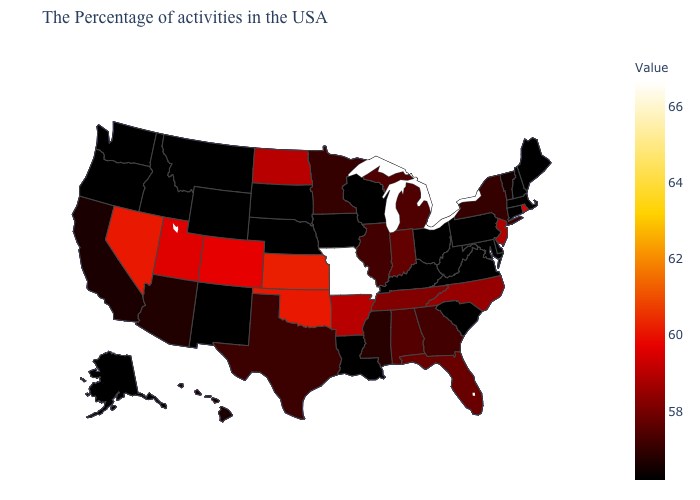Does Montana have the lowest value in the West?
Short answer required. Yes. Is the legend a continuous bar?
Concise answer only. Yes. Which states have the lowest value in the USA?
Write a very short answer. Maine, Massachusetts, New Hampshire, Connecticut, Delaware, Maryland, Pennsylvania, Virginia, South Carolina, West Virginia, Ohio, Kentucky, Wisconsin, Louisiana, Iowa, Nebraska, South Dakota, Wyoming, New Mexico, Montana, Idaho, Washington, Oregon, Alaska. Does Kentucky have the lowest value in the USA?
Keep it brief. Yes. Is the legend a continuous bar?
Be succinct. Yes. Is the legend a continuous bar?
Concise answer only. Yes. Does South Dakota have the lowest value in the MidWest?
Answer briefly. Yes. 